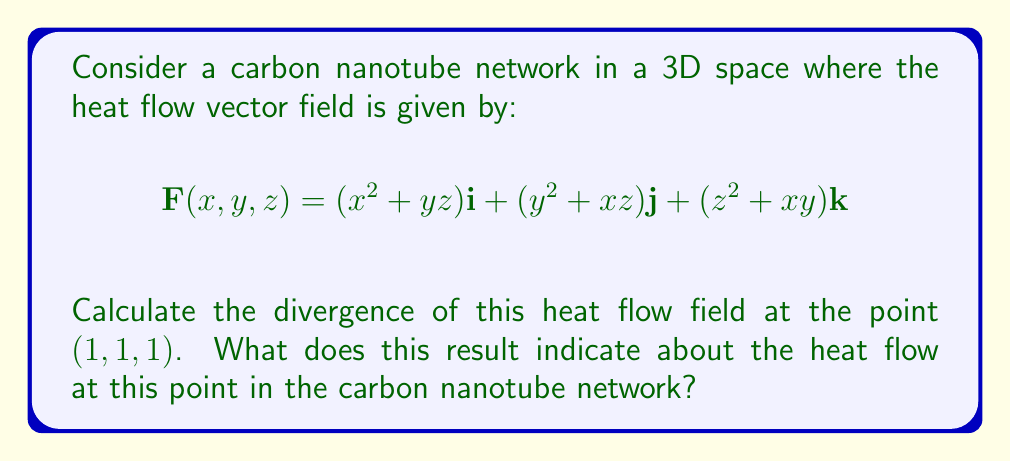Provide a solution to this math problem. To solve this problem, we need to follow these steps:

1) The divergence of a vector field $\mathbf{F}(x,y,z) = P\mathbf{i} + Q\mathbj + R\mathbf{k}$ is given by:

   $$\text{div}\mathbf{F} = \nabla \cdot \mathbf{F} = \frac{\partial P}{\partial x} + \frac{\partial Q}{\partial y} + \frac{\partial R}{\partial z}$$

2) In our case:
   $P = x^2 + yz$
   $Q = y^2 + xz$
   $R = z^2 + xy$

3) Let's calculate each partial derivative:

   $$\frac{\partial P}{\partial x} = 2x$$
   $$\frac{\partial Q}{\partial y} = 2y$$
   $$\frac{\partial R}{\partial z} = 2z$$

4) Now, we can sum these partial derivatives:

   $$\text{div}\mathbf{F} = 2x + 2y + 2z$$

5) We need to evaluate this at the point (1, 1, 1):

   $$\text{div}\mathbf{F}(1,1,1) = 2(1) + 2(1) + 2(1) = 6$$

6) Interpretation: The divergence represents the rate at which heat is flowing out of a point. A positive divergence at (1,1,1) indicates that this point is a source of heat in the carbon nanotube network. The magnitude of 6 suggests a significant outward flow of heat at this point.
Answer: The divergence of the heat flow field at the point (1, 1, 1) is 6. This positive value indicates that the point (1, 1, 1) is a source of heat in the carbon nanotube network, with a significant outward heat flow. 